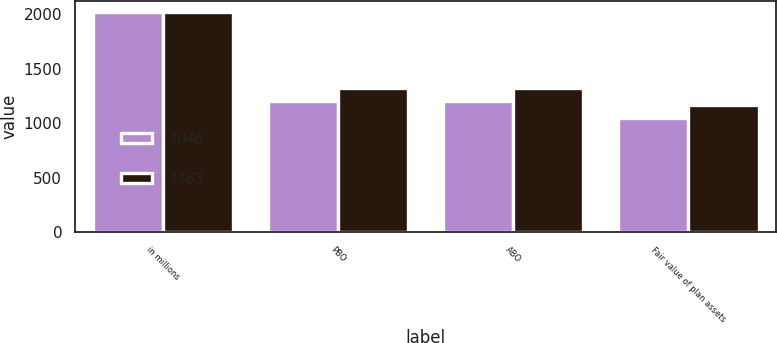Convert chart. <chart><loc_0><loc_0><loc_500><loc_500><stacked_bar_chart><ecel><fcel>in millions<fcel>PBO<fcel>ABO<fcel>Fair value of plan assets<nl><fcel>1046<fcel>2018<fcel>1201<fcel>1201<fcel>1046<nl><fcel>1163<fcel>2017<fcel>1323<fcel>1323<fcel>1163<nl></chart> 